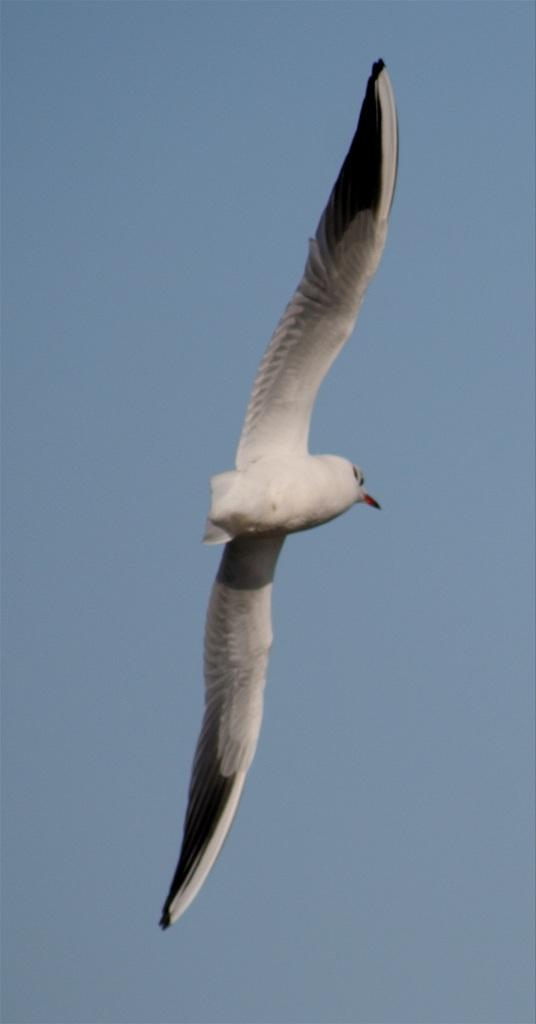What type of animal is in the picture? There is a bird in the picture. What physical features does the bird have? The bird has wings and black and white feathers. What can be seen in the background of the picture? The sky is clear in the background of the picture. How many clocks are present in the picture? There are no clocks visible in the picture; it features a bird with black and white feathers against a clear sky. What is the bird's opinion on the concept of existence? The bird's opinion on the concept of existence cannot be determined from the image, as it is a photograph and not capable of expressing opinions. 